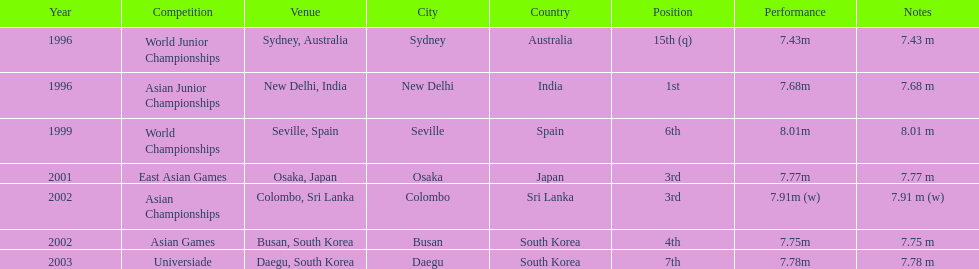Tell me the only venue in spain. Seville, Spain. 